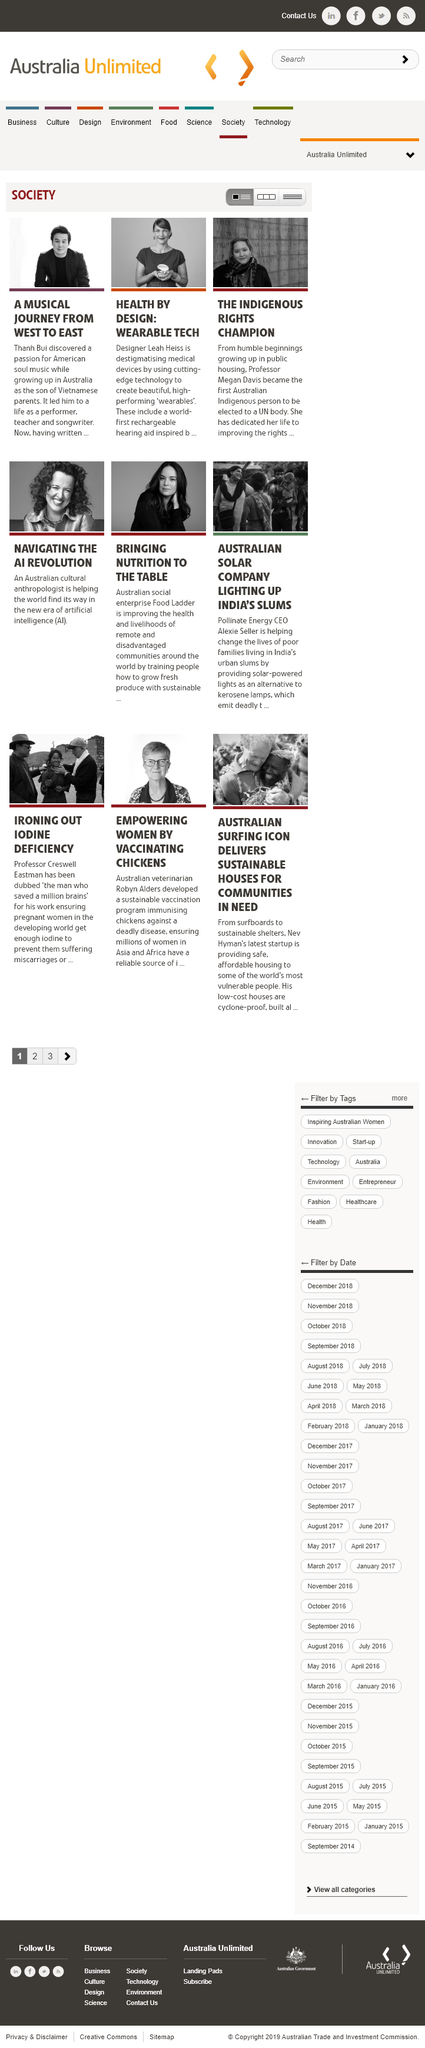Point out several critical features in this image. Thanh Bui grew up in Australia. Professor Megan Davis is known as The Indigenous Rights Champion. Thanh Bui's parents are Vietnamese. 